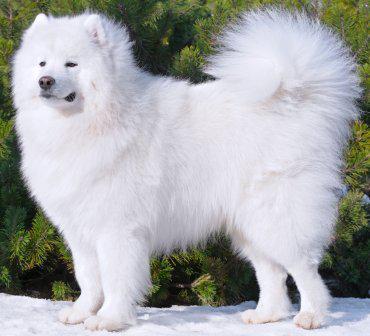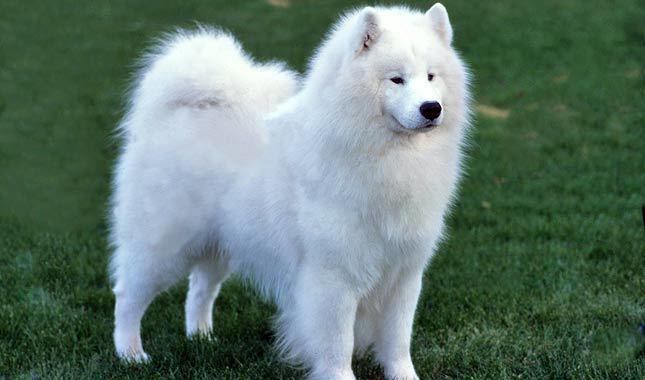The first image is the image on the left, the second image is the image on the right. Evaluate the accuracy of this statement regarding the images: "At least two dogs have have visible tongues.". Is it true? Answer yes or no. No. 